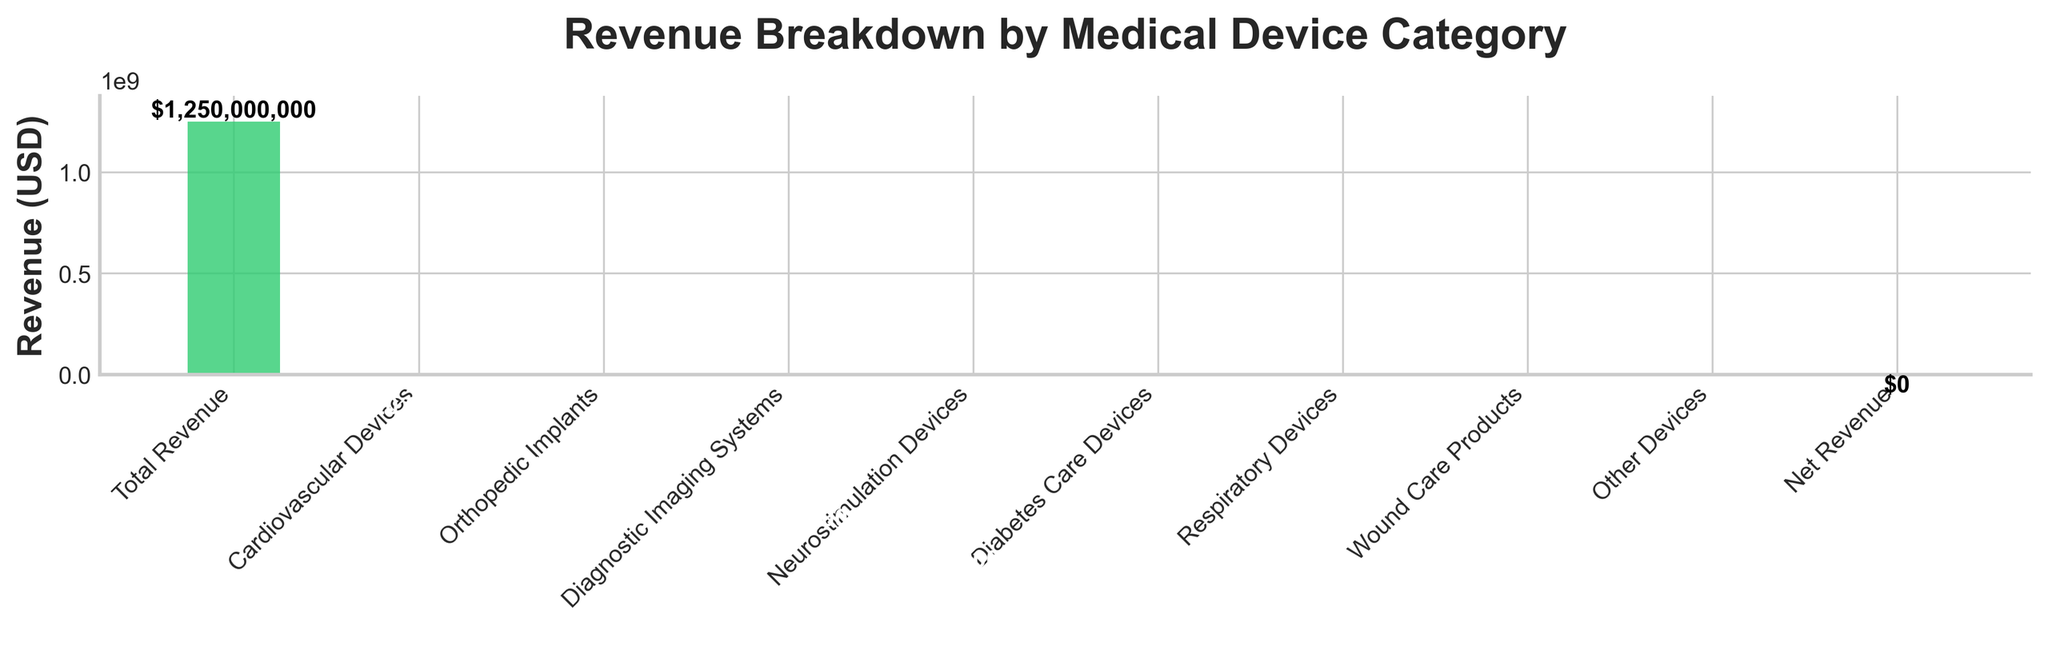What's the title of the chart? The title of the chart is displayed at the top of the figure, and it reads "Revenue Breakdown by Medical Device Category".
Answer: Revenue Breakdown by Medical Device Category How many categories of medical devices are shown in the chart? The chart lists the categories along the x-axis. There are a total of 8 main device categories shown.
Answer: 8 Which category has the largest negative impact on revenue? The length of the bars below the x-axis indicates negative revenue. Cardiovascular Devices has the longest bar, indicating the largest negative impact.
Answer: Cardiovascular Devices What is the total revenue before all subtractions? The initial total revenue is represented by the first bar at the left-most side of the chart, which shows $1,250,000,000.
Answer: $1,250,000,000 How much revenue do Neurostimulation Devices account for? The height of the bar for Neurostimulation Devices is labeled in the chart. It shows a negative impact of $180,000,000.
Answer: -$180,000,000 What would the revenue be after subtracting the Orthopedic Implants and Diagnostic Imaging Systems revenues from the initial total? Subtract the negative impact of Orthopedic Implants (-$280,000,000) and Diagnostic Imaging Systems (-$225,000,000) from the initial total ($1,250,000,000). The calculation is $1,250,000,000 - $280,000,000 - $225,000,000 = $745,000,000.
Answer: $745,000,000 Which two categories combined contribute the least negative revenue impact? The two smallest bars representing negative revenue are Wound Care Products (-$40,000,000) and Other Devices (-$20,000,000). Their combined impact is -$40,000,000 + -$20,000,000.
Answer: -$60,000,000 What is the net revenue shown at the end of the chart? The last bar represents the net revenue, which is labeled as $0.
Answer: $0 How does the negative impact of Respiratory Devices compare to Diabetes Care Devices? Compare the lengths of the bars for each category: Respiratory Devices have a negative impact of -$75,000,000, while Diabetes Care Devices have a negative impact of -$110,000,000.
Answer: Respiratory Devices have a smaller negative impact than Diabetes Care Devices What is the cumulative negative impact on revenue by all the specified device categories combined? Sum the negative impacts: -$320,000,000 (Cardiovascular Devices) -$280,000,000 (Orthopedic Implants) -$225,000,000 (Diagnostic Imaging Systems) -$180,000,000 (Neurostimulation Devices) -$110,000,000 (Diabetes Care Devices) -$75,000,000 (Respiratory Devices) -$40,000,000 (Wound Care Products) -$20,000,000 (Other Devices). The cumulative impact is -$1,250,000,000.
Answer: -$1,250,000,000 